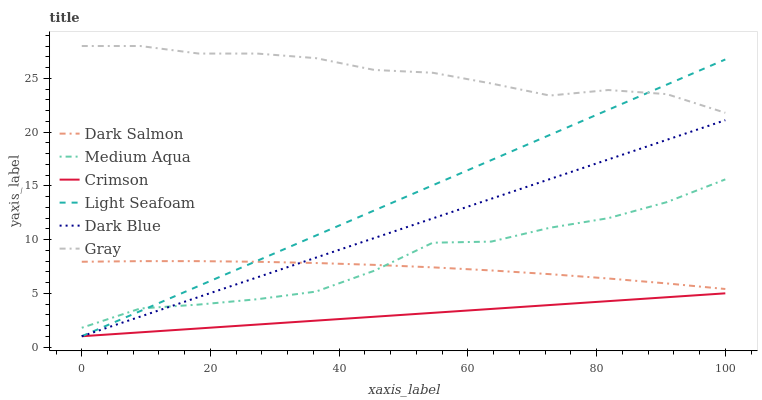Does Crimson have the minimum area under the curve?
Answer yes or no. Yes. Does Gray have the maximum area under the curve?
Answer yes or no. Yes. Does Dark Salmon have the minimum area under the curve?
Answer yes or no. No. Does Dark Salmon have the maximum area under the curve?
Answer yes or no. No. Is Crimson the smoothest?
Answer yes or no. Yes. Is Medium Aqua the roughest?
Answer yes or no. Yes. Is Dark Salmon the smoothest?
Answer yes or no. No. Is Dark Salmon the roughest?
Answer yes or no. No. Does Dark Blue have the lowest value?
Answer yes or no. Yes. Does Dark Salmon have the lowest value?
Answer yes or no. No. Does Gray have the highest value?
Answer yes or no. Yes. Does Dark Salmon have the highest value?
Answer yes or no. No. Is Crimson less than Medium Aqua?
Answer yes or no. Yes. Is Gray greater than Dark Blue?
Answer yes or no. Yes. Does Light Seafoam intersect Gray?
Answer yes or no. Yes. Is Light Seafoam less than Gray?
Answer yes or no. No. Is Light Seafoam greater than Gray?
Answer yes or no. No. Does Crimson intersect Medium Aqua?
Answer yes or no. No. 